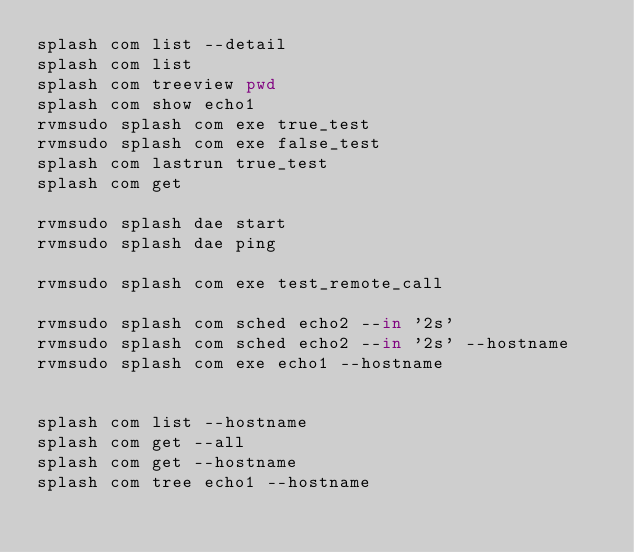<code> <loc_0><loc_0><loc_500><loc_500><_Bash_>splash com list --detail 
splash com list 
splash com treeview pwd
splash com show echo1
rvmsudo splash com exe true_test
rvmsudo splash com exe false_test
splash com lastrun true_test
splash com get 

rvmsudo splash dae start 
rvmsudo splash dae ping 

rvmsudo splash com exe test_remote_call

rvmsudo splash com sched echo2 --in '2s'
rvmsudo splash com sched echo2 --in '2s' --hostname
rvmsudo splash com exe echo1 --hostname


splash com list --hostname
splash com get --all
splash com get --hostname 
splash com tree echo1 --hostname

</code> 